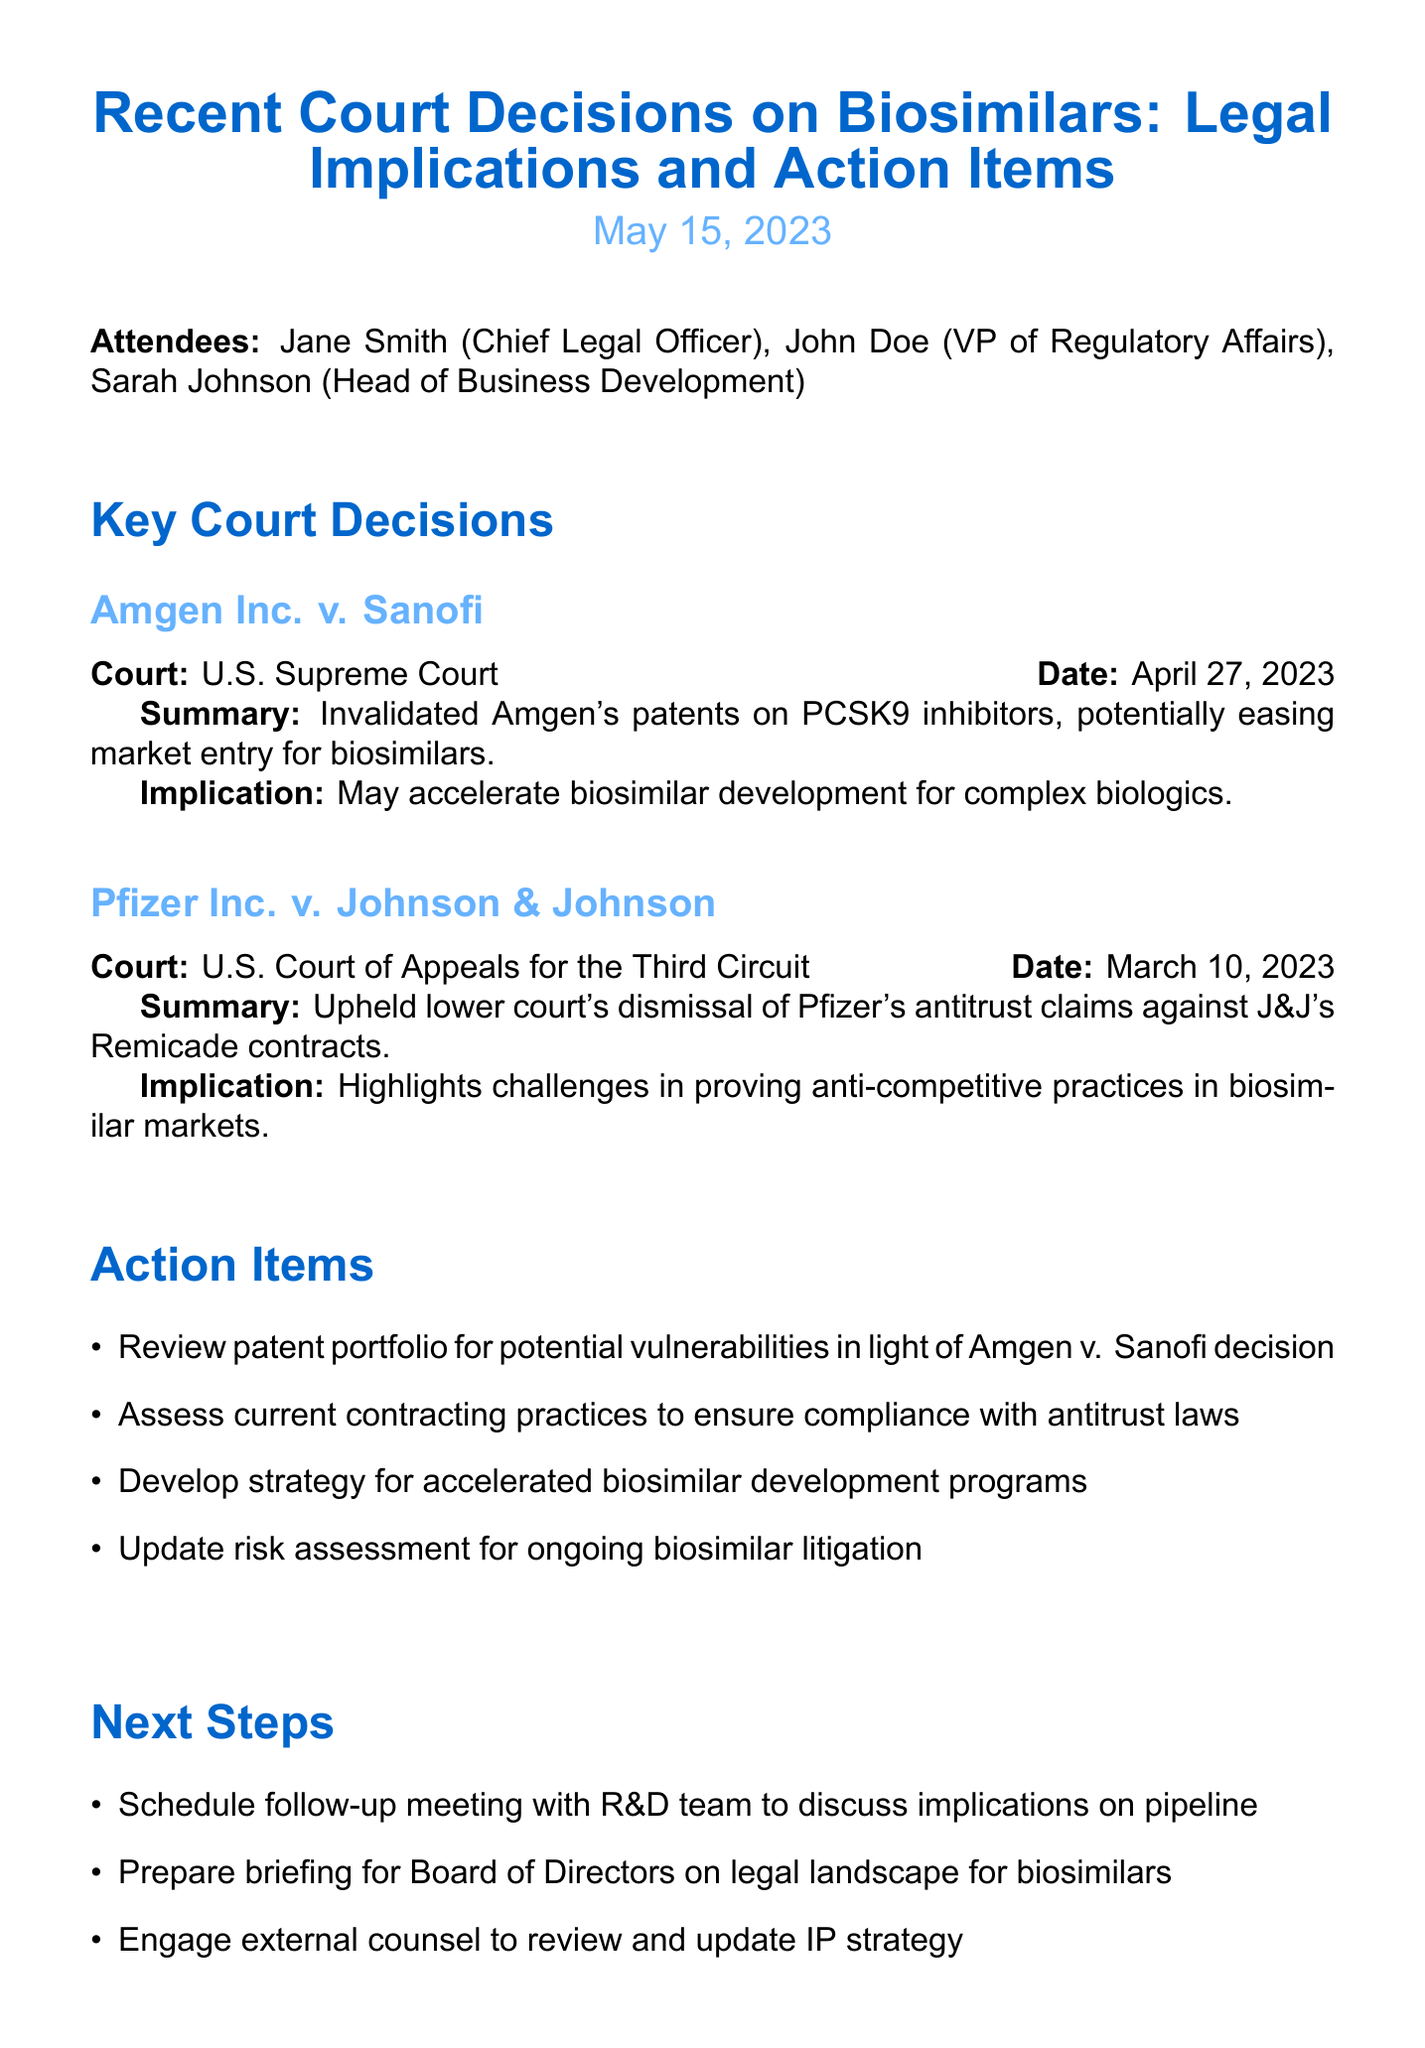what is the date of the meeting? The date of the meeting is clearly stated in the document as May 15, 2023.
Answer: May 15, 2023 who is the Chief Legal Officer? The document lists Jane Smith as the Chief Legal Officer among the attendees.
Answer: Jane Smith what was the decision in Amgen Inc. v. Sanofi? The document summarizes the decision as invalidating Amgen's patents on PCSK9 inhibitors.
Answer: Invalidated Amgen's patents on PCSK9 inhibitors what is one implication of Amgen v. Sanofi? The document mentions that one implication may accelerate biosimilar development for complex biologics.
Answer: May accelerate biosimilar development for complex biologics how many key court decisions are summarized? The document outlines a total of two key court decisions related to biosimilars.
Answer: Two what is the first action item listed? The first action item listed in the document is to review the patent portfolio for potential vulnerabilities.
Answer: Review patent portfolio for potential vulnerabilities in light of Amgen v. Sanofi decision what is the next step regarding the R&D team? The next step involves scheduling a follow-up meeting with the R&D team.
Answer: Schedule follow-up meeting with R&D team to discuss implications on pipeline who attended the meeting? The attendees listed in the document are Jane Smith, John Doe, and Sarah Johnson.
Answer: Jane Smith, John Doe, Sarah Johnson what court heard the Pfizer Inc. v. Johnson & Johnson case? The document specifies that the case was heard by the U.S. Court of Appeals for the Third Circuit.
Answer: U.S. Court of Appeals for the Third Circuit 